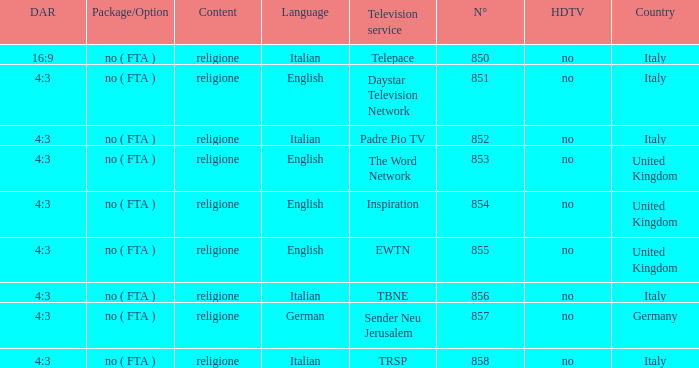What television service is in italy and is in english? Daystar Television Network. I'm looking to parse the entire table for insights. Could you assist me with that? {'header': ['DAR', 'Package/Option', 'Content', 'Language', 'Television service', 'N°', 'HDTV', 'Country'], 'rows': [['16:9', 'no ( FTA )', 'religione', 'Italian', 'Telepace', '850', 'no', 'Italy'], ['4:3', 'no ( FTA )', 'religione', 'English', 'Daystar Television Network', '851', 'no', 'Italy'], ['4:3', 'no ( FTA )', 'religione', 'Italian', 'Padre Pio TV', '852', 'no', 'Italy'], ['4:3', 'no ( FTA )', 'religione', 'English', 'The Word Network', '853', 'no', 'United Kingdom'], ['4:3', 'no ( FTA )', 'religione', 'English', 'Inspiration', '854', 'no', 'United Kingdom'], ['4:3', 'no ( FTA )', 'religione', 'English', 'EWTN', '855', 'no', 'United Kingdom'], ['4:3', 'no ( FTA )', 'religione', 'Italian', 'TBNE', '856', 'no', 'Italy'], ['4:3', 'no ( FTA )', 'religione', 'German', 'Sender Neu Jerusalem', '857', 'no', 'Germany'], ['4:3', 'no ( FTA )', 'religione', 'Italian', 'TRSP', '858', 'no', 'Italy']]} 